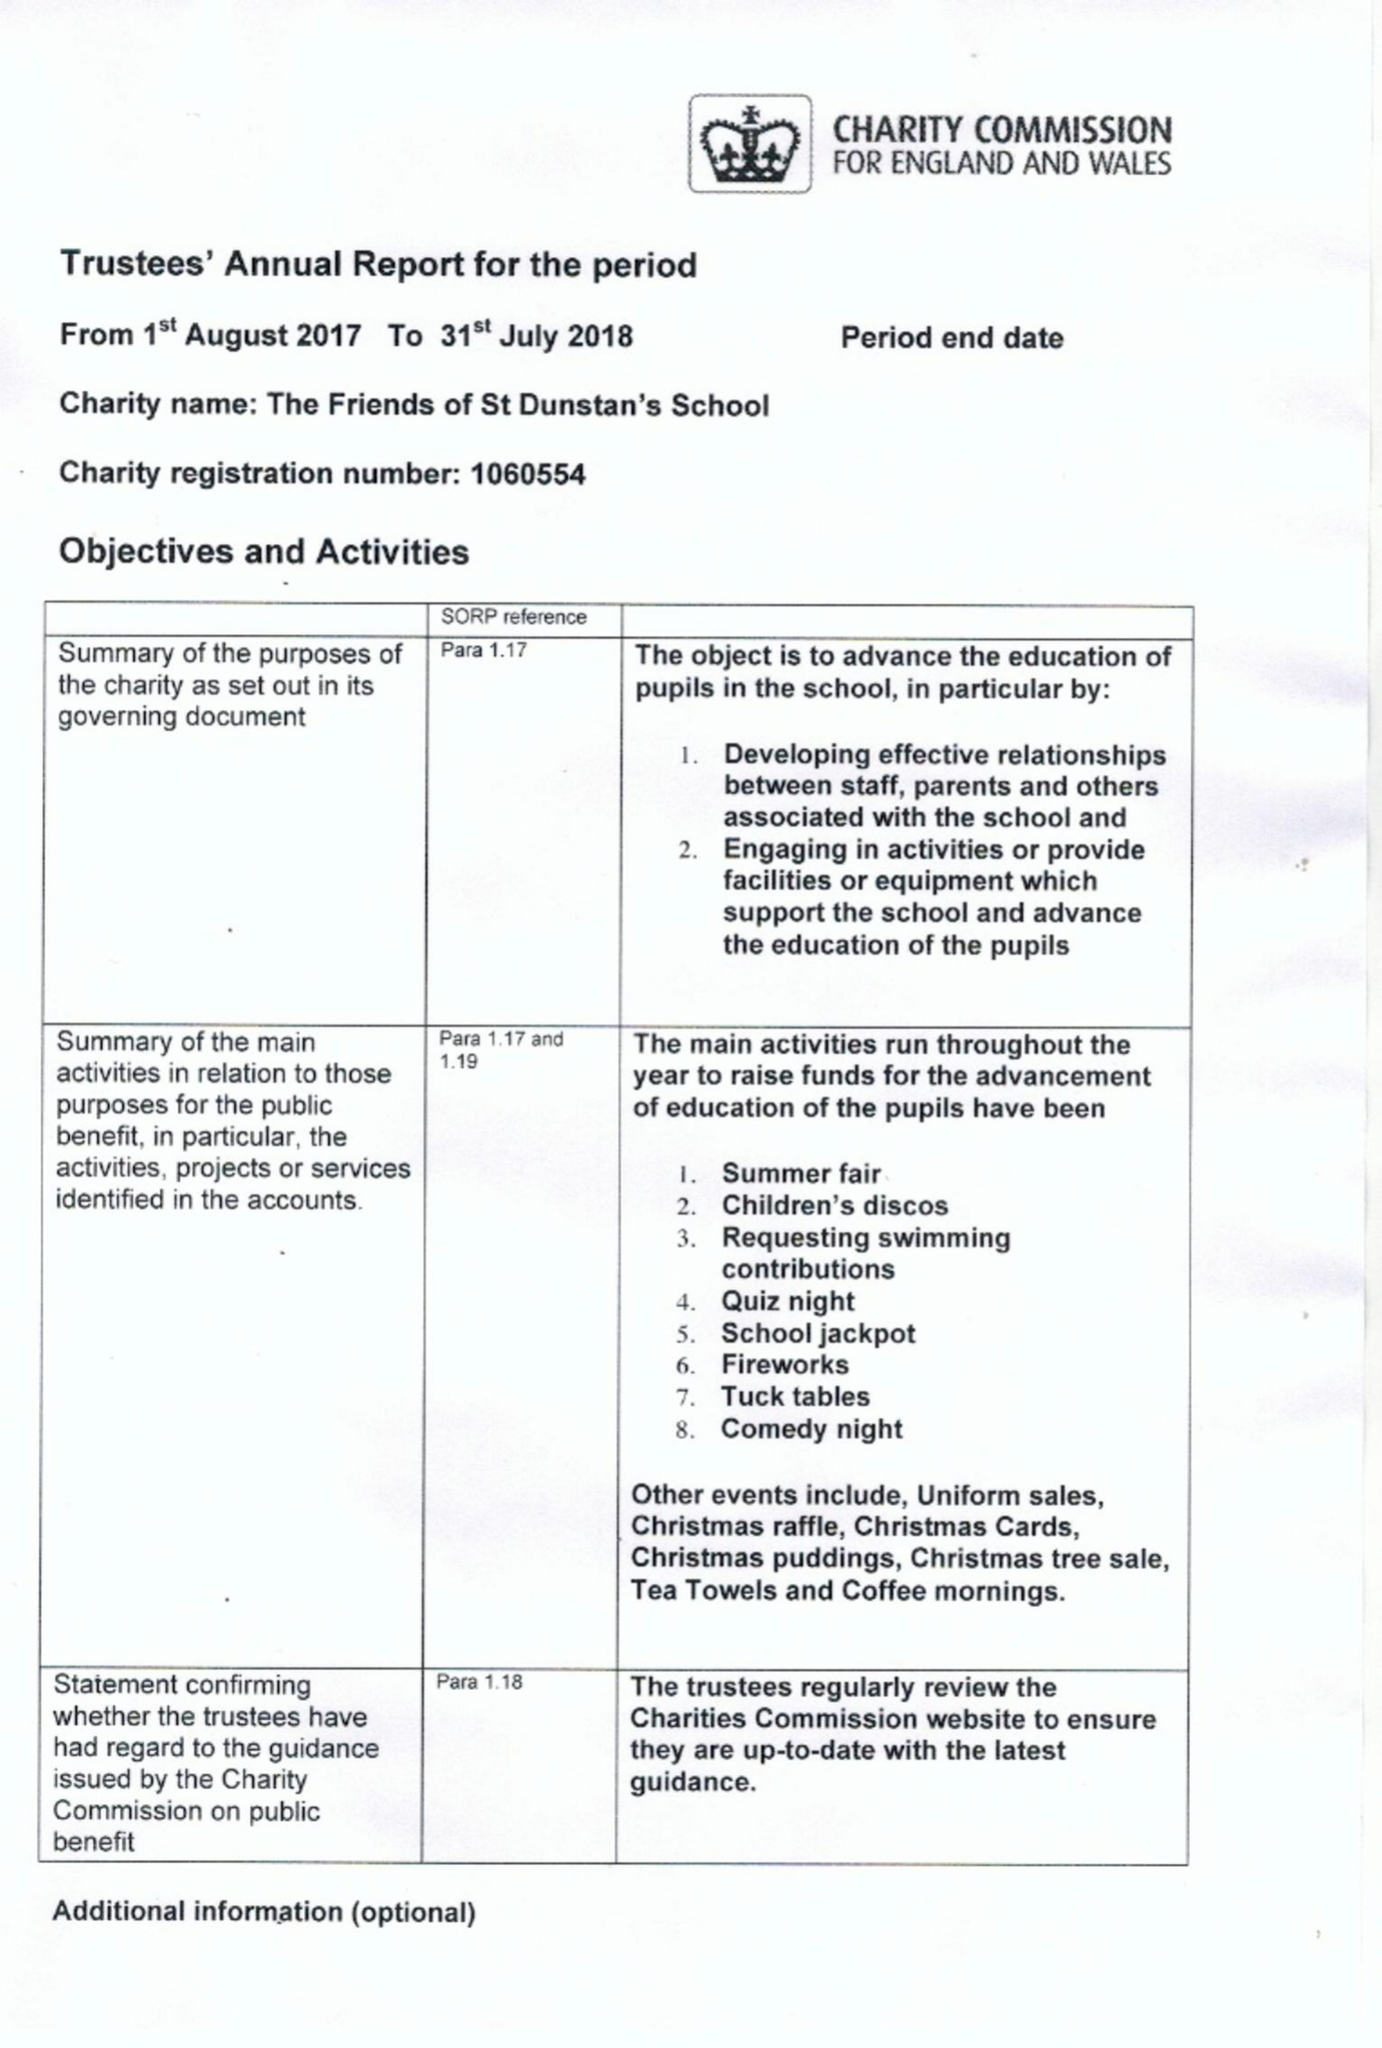What is the value for the report_date?
Answer the question using a single word or phrase. 2018-07-31 